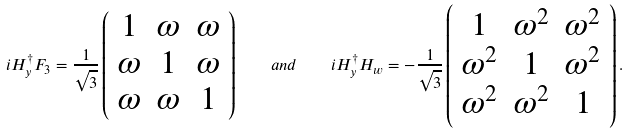<formula> <loc_0><loc_0><loc_500><loc_500>i H ^ { \dagger } _ { y } F _ { 3 } = \frac { 1 } { \sqrt { 3 } } \left ( \begin{array} { c c c } 1 & \omega & \omega \\ \omega & 1 & \omega \\ \omega & \omega & 1 \end{array} \right ) \quad a n d \quad i H ^ { \dagger } _ { y } H _ { w } = - \frac { 1 } { \sqrt { 3 } } \left ( \begin{array} { c c c } 1 & \omega ^ { 2 } & \omega ^ { 2 } \\ \omega ^ { 2 } & 1 & \omega ^ { 2 } \\ \omega ^ { 2 } & \omega ^ { 2 } & 1 \end{array} \right ) .</formula> 